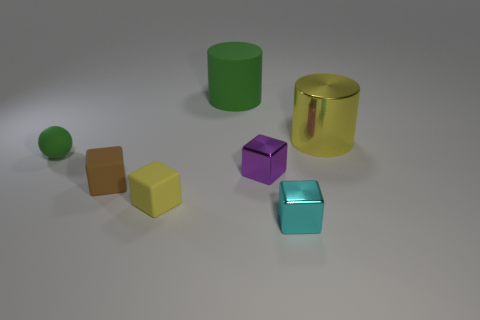Subtract all brown blocks. How many blocks are left? 3 Subtract 1 blocks. How many blocks are left? 3 Subtract all small purple blocks. How many blocks are left? 3 Subtract all green cubes. Subtract all red cylinders. How many cubes are left? 4 Add 1 cyan objects. How many objects exist? 8 Subtract all cubes. How many objects are left? 3 Subtract all large rubber things. Subtract all brown rubber cubes. How many objects are left? 5 Add 1 small cyan cubes. How many small cyan cubes are left? 2 Add 5 small blue metal balls. How many small blue metal balls exist? 5 Subtract 1 green cylinders. How many objects are left? 6 